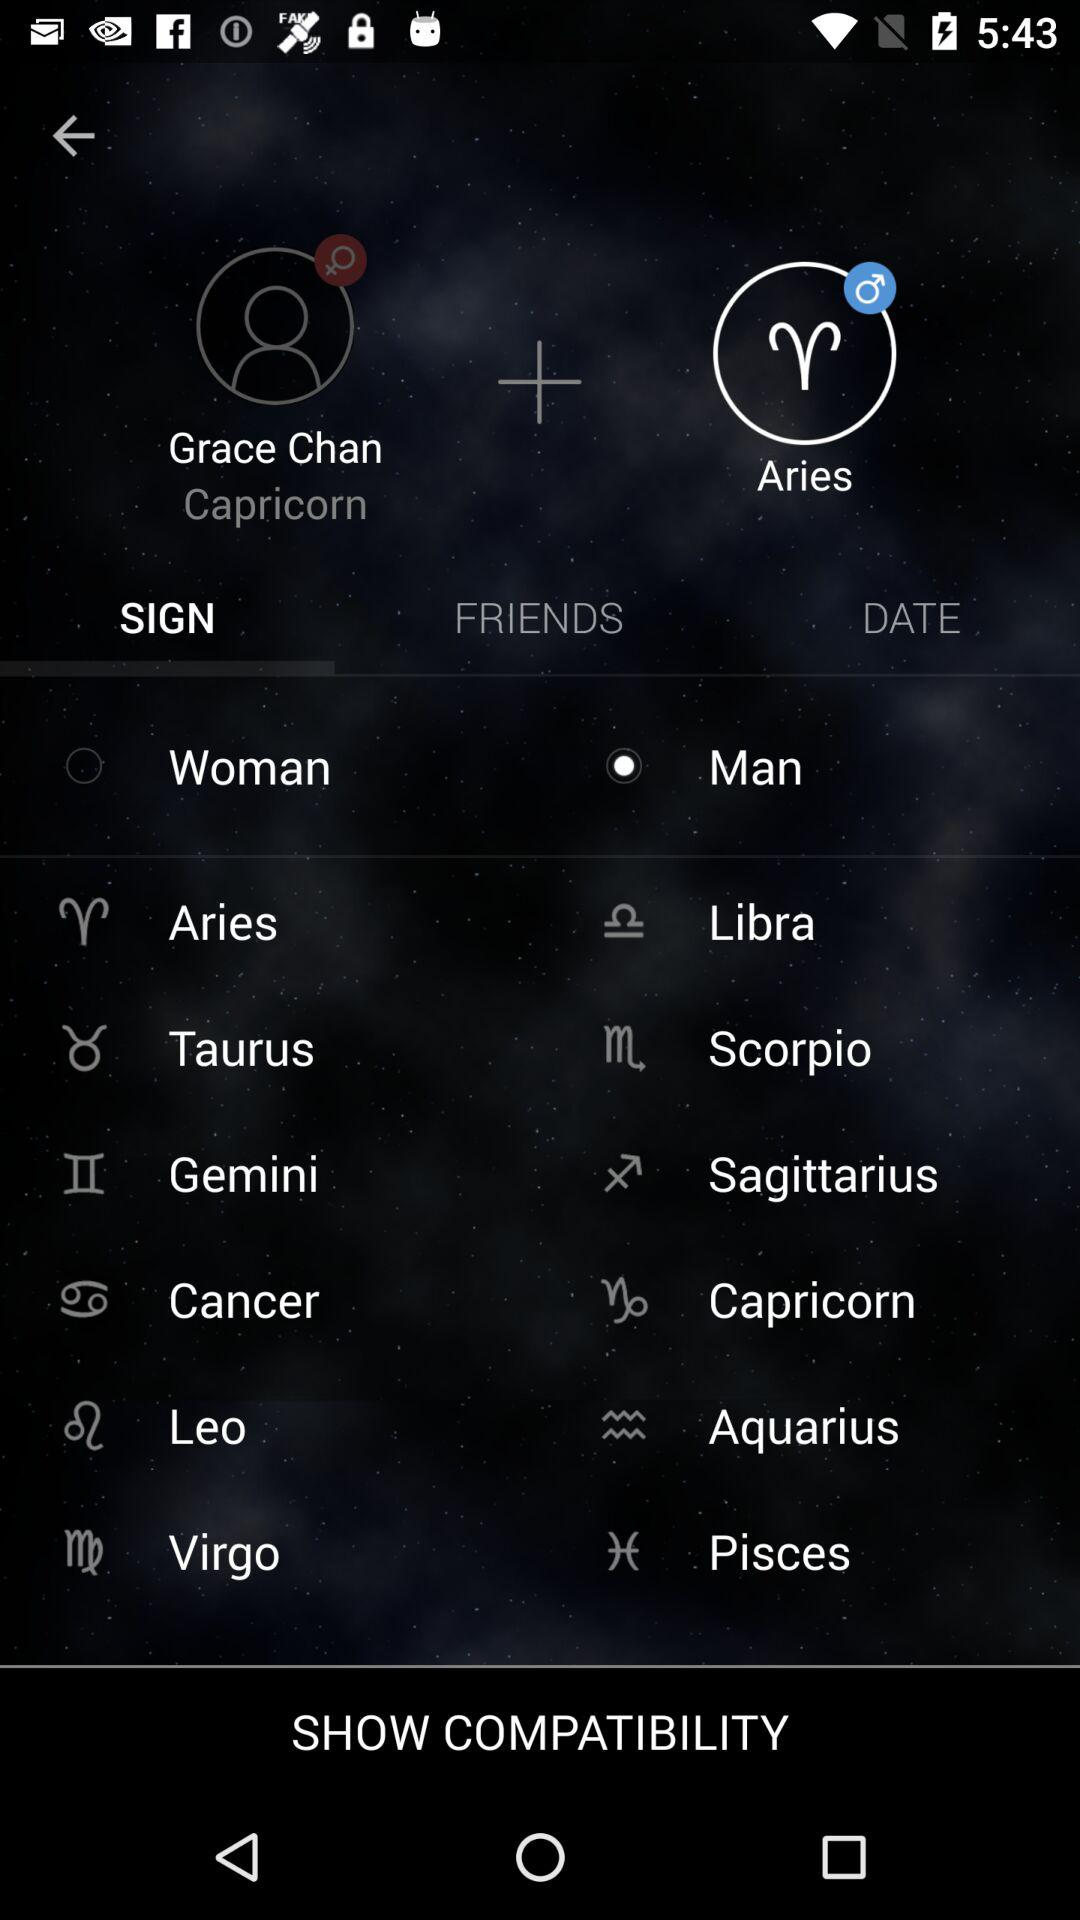What is the zodiac sign of the user? The zodiac sign is "Capricorn". 